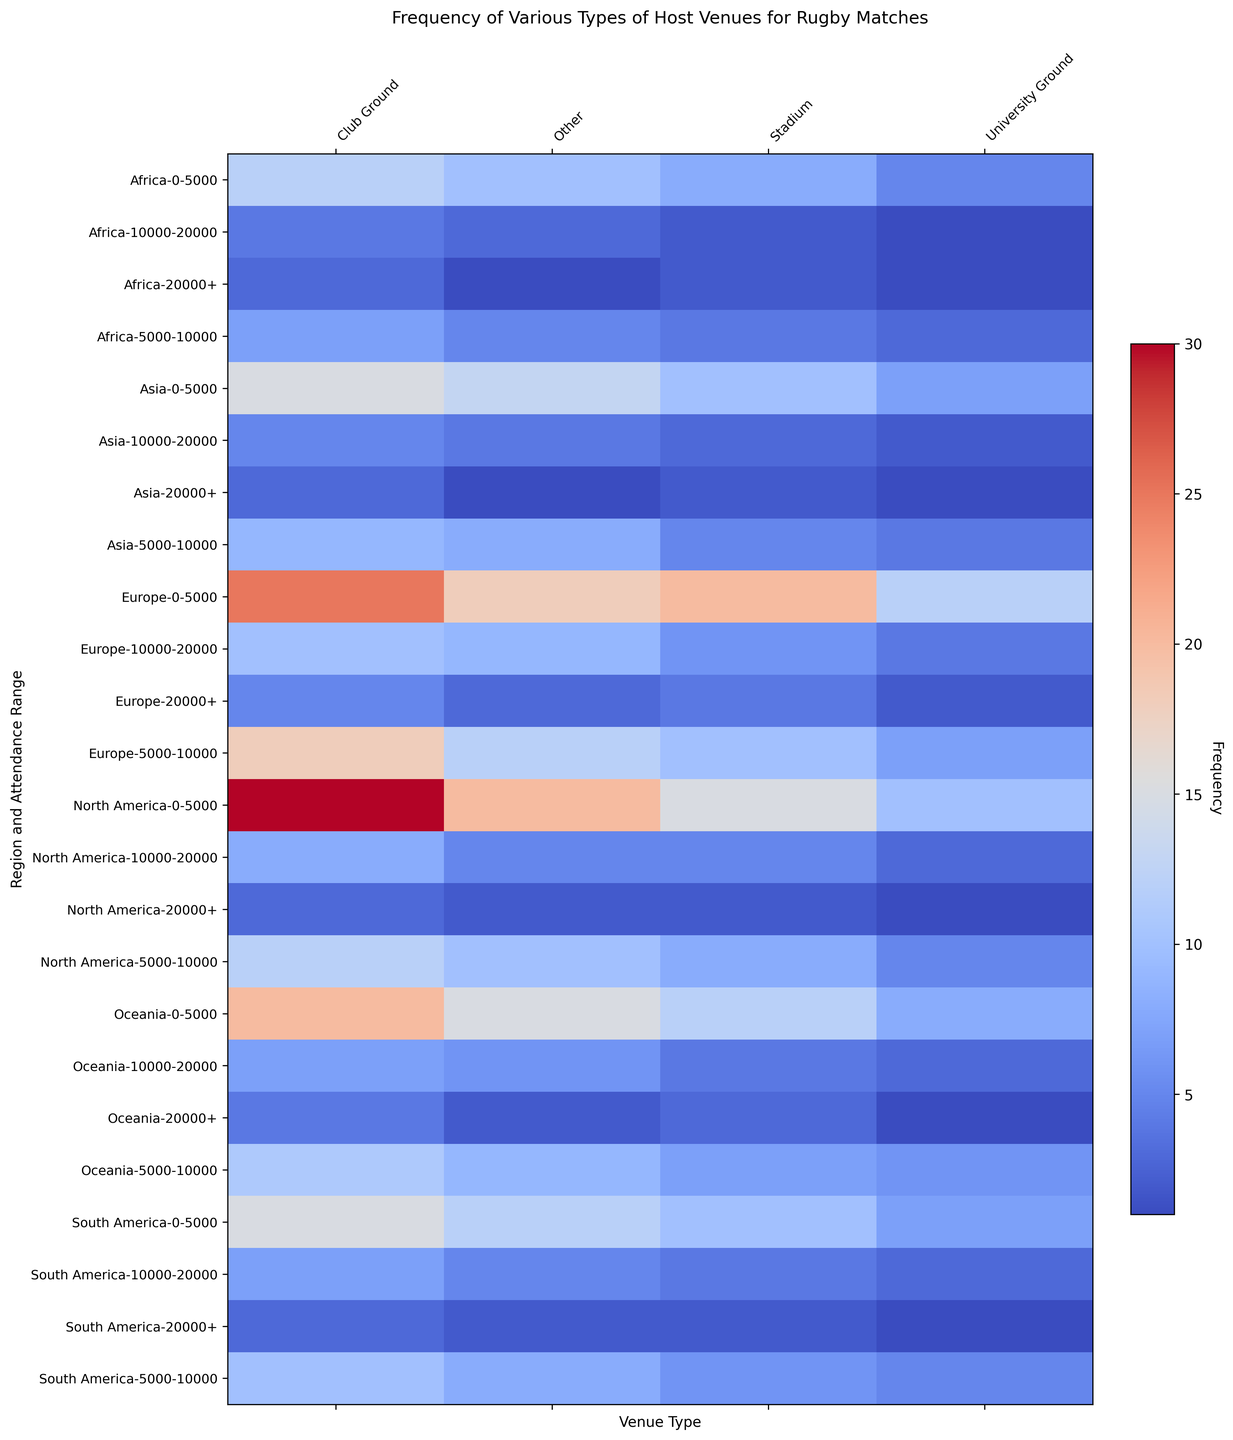What region and attendance range has the highest frequency for Stadium venues? To find the highest frequency for Stadium venues, identify the region and attendance range with the darkest red color in the Stadium column.
Answer: Europe, 0-5000 Which type of venue has the lowest frequency in the North America region for the 20000+ attendance range? Look at the North America region and the 20000+ attendance range, then identify which venue type column has the lightest color (indicating the lowest frequency).
Answer: University Ground Out of all regions, which attendance range in Oceania has the most frequent use of Club Grounds? Examine the Oceania rows; find the row with the highest frequency (darkest red color) in the Club Ground column.
Answer: 0-5000 For the Europe region, which venue type increases in frequency from the 10000-20000 to the 20000+ attendance range? Compare the color shifts between the 10000-20000 and 20000+ rows in Europe for each venue type to see which one gets darker (indicating an increase in frequency).
Answer: Stadium Is the frequency of Other venues higher in Asia or South America for the 5000-10000 attendance range? Compare the colors in the Other column under 5000-10000 attendance range for both Asia and South America; darker color indicates higher frequency.
Answer: Asia What region and attendance range combination uses University Grounds most frequently? Identify the region and attendance range with the darkest red color in the University Ground column.
Answer: Europe, 0-5000 How does the frequency of Stadium venues in North America compare for the 0-5000 and 20000+ attendance ranges? Compare the colors in the Stadium column for North America between 0-5000 and 20000+ attendance ranges; darker color indicates higher frequency.
Answer: 0-5000 is higher Which venue type is most frequently used in Africa for rugby matches with an attendance range of 0-5000? Look at the Africa region for the 0-5000 attendance range and identify which venue type column has the darkest red color.
Answer: Club Ground In South America, which attendance range shows the greatest difference in frequency between Club Grounds and Stadium venues? Compare the frequencies (color differences) between the Club Grounds and Stadium columns for each attendance range in South America. The largest color difference represents the greatest difference.
Answer: 5000-10000 What is the common trend in the frequency of Stadium venues as the attendance range increases across all regions? Observe the color changes in the Stadium column as the attendance range increases from 0-5000 to 20000+ for all regions, noting if the colors get lighter or darker.
Answer: Decreases 